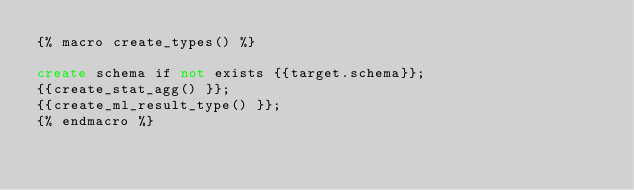Convert code to text. <code><loc_0><loc_0><loc_500><loc_500><_SQL_>{% macro create_types() %}

create schema if not exists {{target.schema}};
{{create_stat_agg() }};
{{create_ml_result_type() }};
{% endmacro %}
</code> 